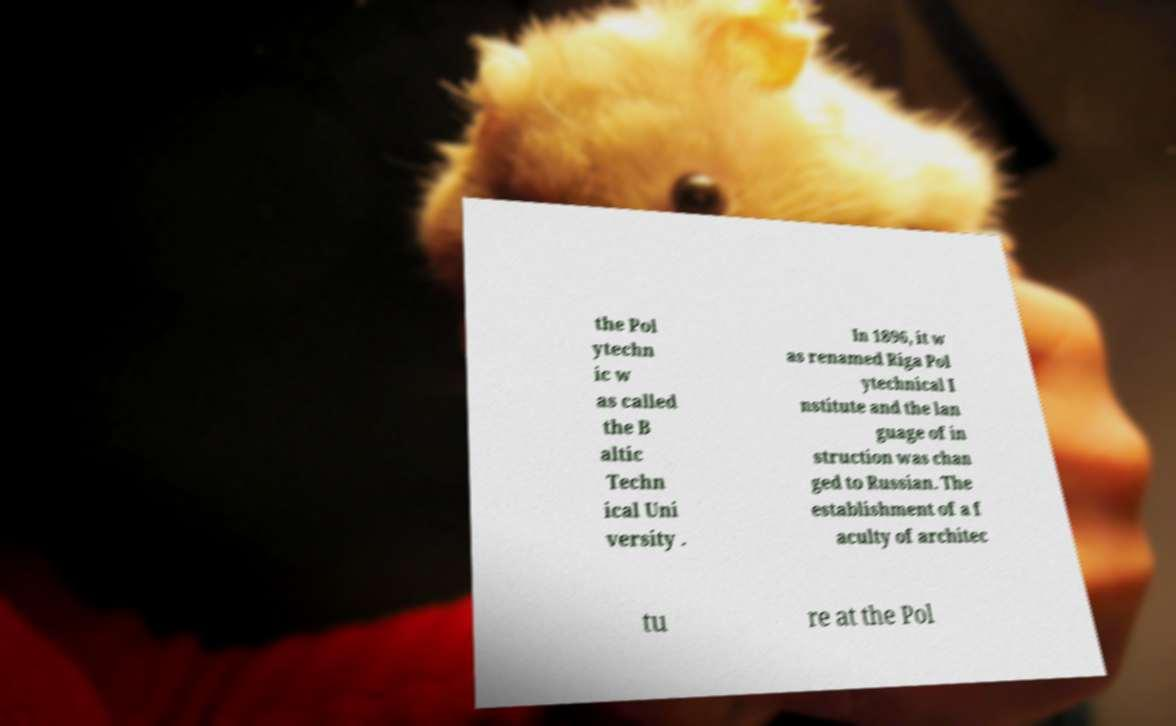Can you read and provide the text displayed in the image?This photo seems to have some interesting text. Can you extract and type it out for me? the Pol ytechn ic w as called the B altic Techn ical Uni versity . In 1896, it w as renamed Riga Pol ytechnical I nstitute and the lan guage of in struction was chan ged to Russian. The establishment of a f aculty of architec tu re at the Pol 